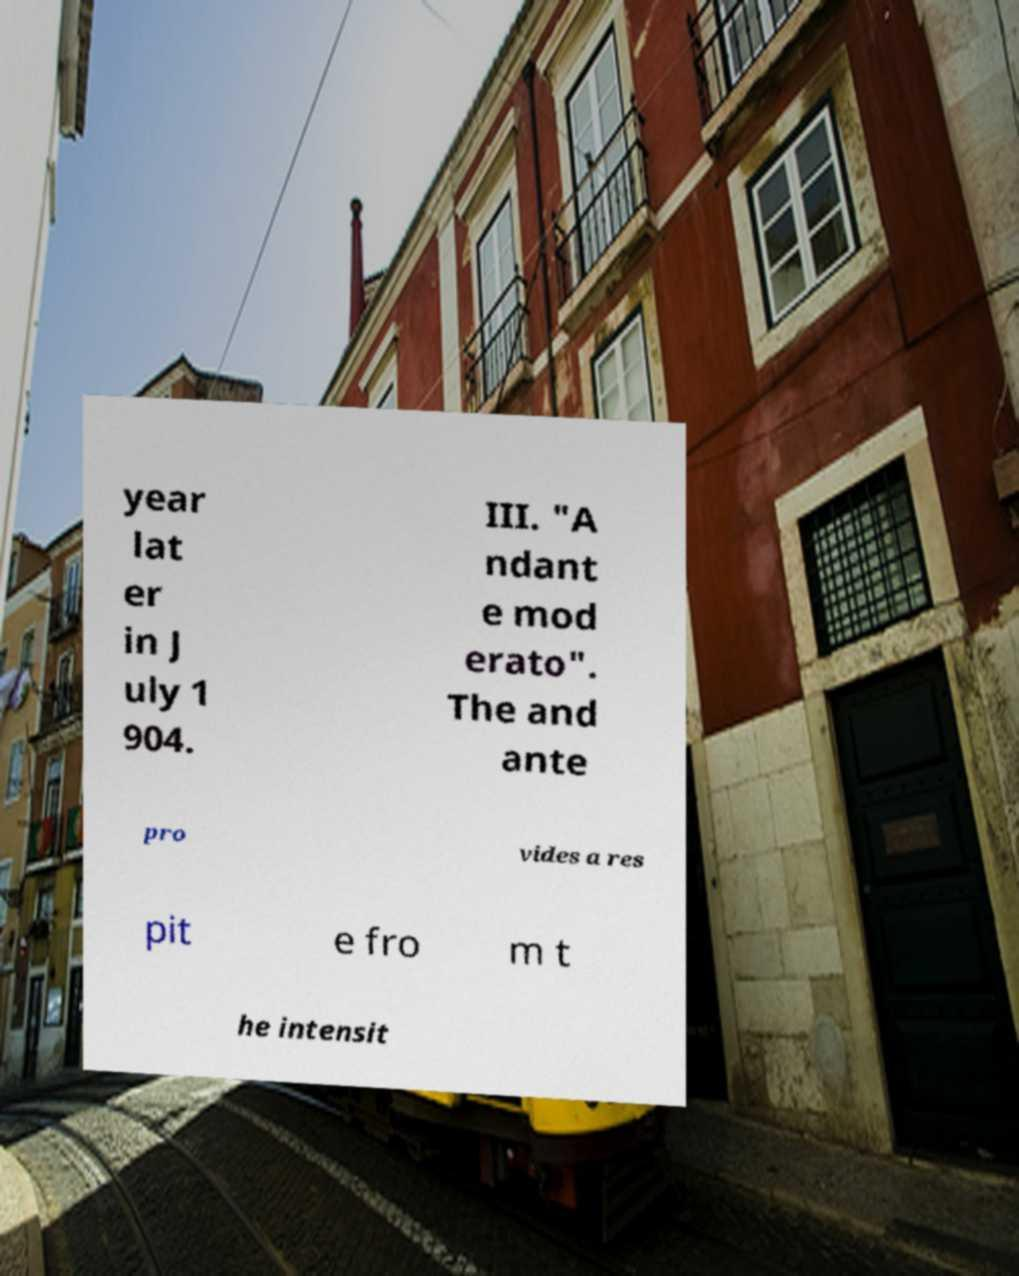For documentation purposes, I need the text within this image transcribed. Could you provide that? year lat er in J uly 1 904. III. "A ndant e mod erato". The and ante pro vides a res pit e fro m t he intensit 